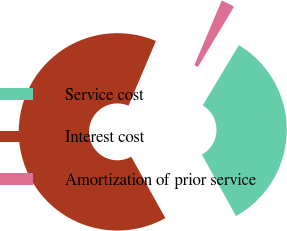<chart> <loc_0><loc_0><loc_500><loc_500><pie_chart><fcel>Service cost<fcel>Interest cost<fcel>Amortization of prior service<nl><fcel>33.33%<fcel>64.44%<fcel>2.22%<nl></chart> 